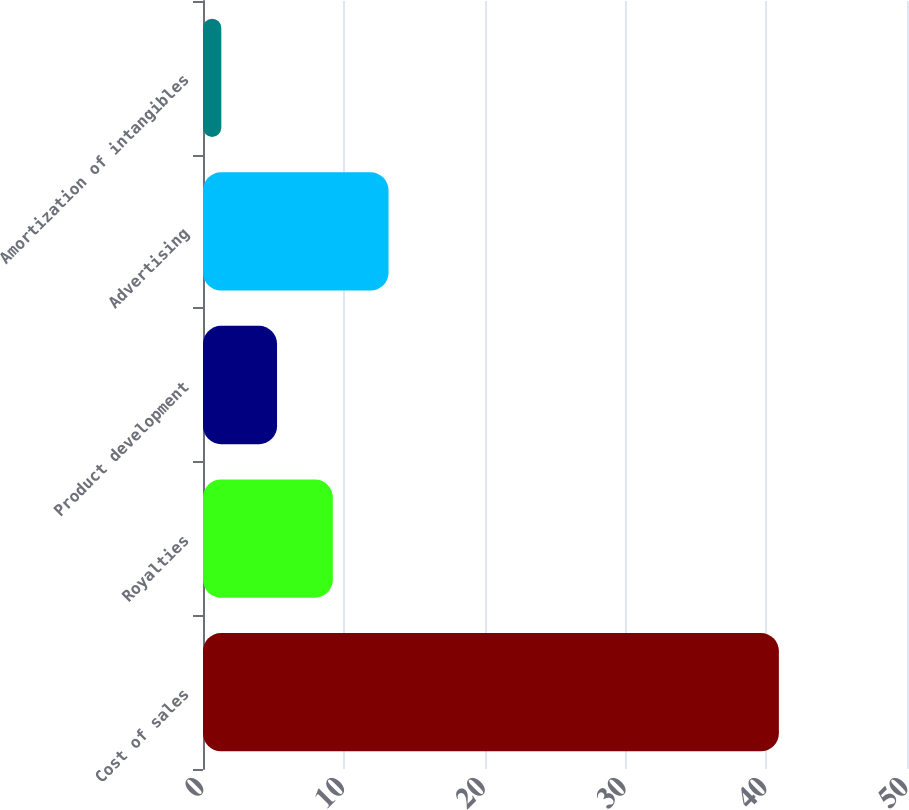<chart> <loc_0><loc_0><loc_500><loc_500><bar_chart><fcel>Cost of sales<fcel>Royalties<fcel>Product development<fcel>Advertising<fcel>Amortization of intangibles<nl><fcel>40.9<fcel>9.22<fcel>5.26<fcel>13.18<fcel>1.3<nl></chart> 